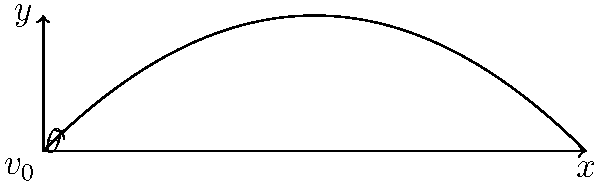A projectile is launched with an initial velocity $v_0 = 50$ m/s at an angle $\theta = 45°$ from the horizontal. Assuming negligible air resistance, write a function in C that calculates the projectile's position $(x, y)$ at any given time $t$. Use the constant $g = 9.8$ m/s² for acceleration due to gravity. To solve this problem, we'll follow these steps:

1) Recall the equations of motion for projectile motion:
   $x(t) = v_0 \cos(\theta) \cdot t$
   $y(t) = v_0 \sin(\theta) \cdot t - \frac{1}{2}gt^2$

2) We'll create a struct to represent the position:
   ```c
   typedef struct {
       double x;
       double y;
   } Position;
   ```

3) Now, let's implement the function:
   ```c
   #include <math.h>

   #define G 9.8
   #define PI 3.14159265358979323846

   Position calculate_position(double v0, double theta_deg, double t) {
       Position pos;
       double theta_rad = theta_deg * PI / 180.0;
       
       pos.x = v0 * cos(theta_rad) * t;
       pos.y = v0 * sin(theta_rad) * t - 0.5 * G * t * t;
       
       return pos;
   }
   ```

4) This function takes the initial velocity $v_0$, angle $\theta$ in degrees, and time $t$ as inputs, and returns a Position struct with the calculated $x$ and $y$ coordinates.

5) We convert the angle from degrees to radians using $\theta_{rad} = \theta_{deg} \cdot \frac{\pi}{180}$.

6) Then we apply the equations of motion to calculate $x$ and $y$.

7) The function returns the Position struct containing the calculated coordinates.
Answer: ```c
Position calculate_position(double v0, double theta_deg, double t) {
    Position pos;
    double theta_rad = theta_deg * PI / 180.0;
    pos.x = v0 * cos(theta_rad) * t;
    pos.y = v0 * sin(theta_rad) * t - 0.5 * G * t * t;
    return pos;
}
``` 